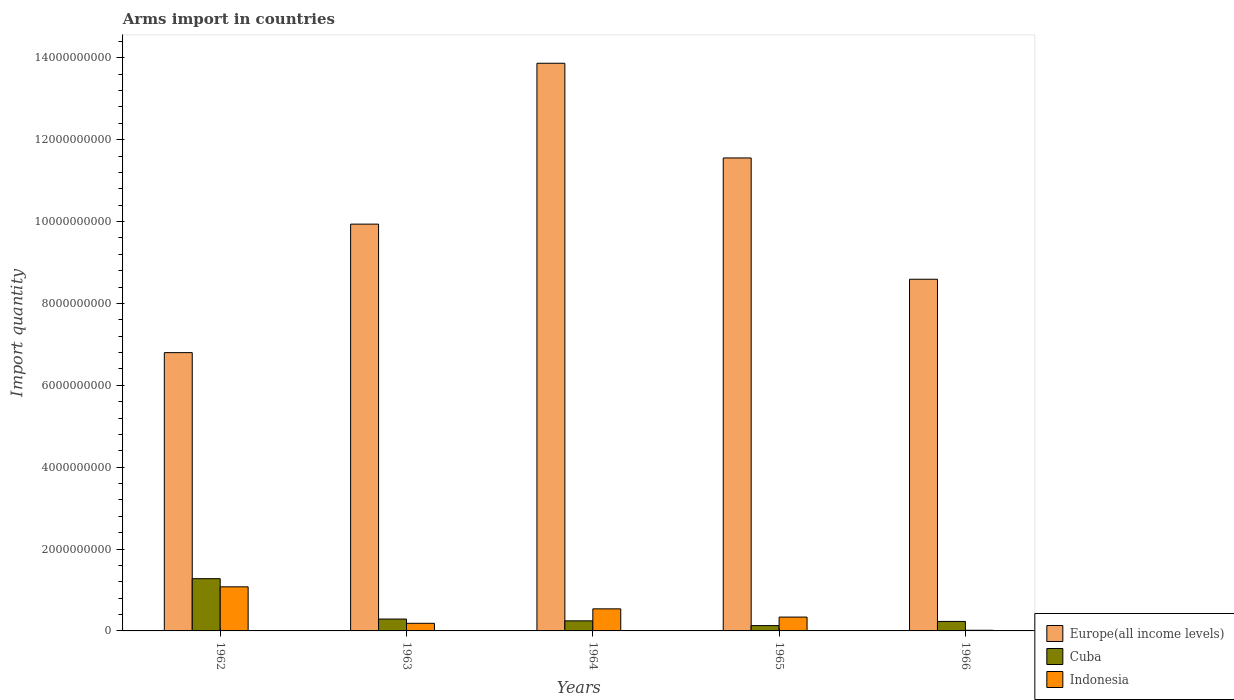Are the number of bars per tick equal to the number of legend labels?
Offer a very short reply. Yes. Are the number of bars on each tick of the X-axis equal?
Your response must be concise. Yes. How many bars are there on the 2nd tick from the right?
Your answer should be very brief. 3. What is the label of the 5th group of bars from the left?
Provide a succinct answer. 1966. What is the total arms import in Cuba in 1963?
Your response must be concise. 2.90e+08. Across all years, what is the maximum total arms import in Indonesia?
Offer a very short reply. 1.08e+09. Across all years, what is the minimum total arms import in Europe(all income levels)?
Offer a terse response. 6.80e+09. In which year was the total arms import in Europe(all income levels) minimum?
Offer a very short reply. 1962. What is the total total arms import in Indonesia in the graph?
Your answer should be compact. 2.16e+09. What is the difference between the total arms import in Cuba in 1964 and that in 1966?
Make the answer very short. 1.40e+07. What is the difference between the total arms import in Indonesia in 1962 and the total arms import in Cuba in 1964?
Provide a succinct answer. 8.31e+08. What is the average total arms import in Indonesia per year?
Provide a short and direct response. 4.31e+08. In the year 1962, what is the difference between the total arms import in Cuba and total arms import in Europe(all income levels)?
Provide a succinct answer. -5.52e+09. What is the ratio of the total arms import in Europe(all income levels) in 1963 to that in 1964?
Your answer should be compact. 0.72. Is the total arms import in Indonesia in 1965 less than that in 1966?
Offer a terse response. No. Is the difference between the total arms import in Cuba in 1964 and 1966 greater than the difference between the total arms import in Europe(all income levels) in 1964 and 1966?
Your response must be concise. No. What is the difference between the highest and the second highest total arms import in Indonesia?
Your response must be concise. 5.38e+08. What is the difference between the highest and the lowest total arms import in Cuba?
Offer a terse response. 1.15e+09. What does the 2nd bar from the right in 1964 represents?
Offer a terse response. Cuba. Are all the bars in the graph horizontal?
Offer a terse response. No. What is the difference between two consecutive major ticks on the Y-axis?
Offer a terse response. 2.00e+09. How are the legend labels stacked?
Provide a short and direct response. Vertical. What is the title of the graph?
Ensure brevity in your answer.  Arms import in countries. Does "New Caledonia" appear as one of the legend labels in the graph?
Offer a terse response. No. What is the label or title of the Y-axis?
Provide a short and direct response. Import quantity. What is the Import quantity in Europe(all income levels) in 1962?
Offer a very short reply. 6.80e+09. What is the Import quantity of Cuba in 1962?
Make the answer very short. 1.28e+09. What is the Import quantity in Indonesia in 1962?
Provide a short and direct response. 1.08e+09. What is the Import quantity in Europe(all income levels) in 1963?
Keep it short and to the point. 9.94e+09. What is the Import quantity of Cuba in 1963?
Provide a short and direct response. 2.90e+08. What is the Import quantity in Indonesia in 1963?
Your answer should be compact. 1.86e+08. What is the Import quantity in Europe(all income levels) in 1964?
Provide a succinct answer. 1.39e+1. What is the Import quantity of Cuba in 1964?
Make the answer very short. 2.46e+08. What is the Import quantity of Indonesia in 1964?
Keep it short and to the point. 5.39e+08. What is the Import quantity of Europe(all income levels) in 1965?
Give a very brief answer. 1.16e+1. What is the Import quantity in Cuba in 1965?
Offer a very short reply. 1.30e+08. What is the Import quantity of Indonesia in 1965?
Your answer should be very brief. 3.38e+08. What is the Import quantity of Europe(all income levels) in 1966?
Your response must be concise. 8.59e+09. What is the Import quantity in Cuba in 1966?
Provide a succinct answer. 2.32e+08. What is the Import quantity of Indonesia in 1966?
Offer a very short reply. 1.60e+07. Across all years, what is the maximum Import quantity in Europe(all income levels)?
Provide a short and direct response. 1.39e+1. Across all years, what is the maximum Import quantity in Cuba?
Provide a short and direct response. 1.28e+09. Across all years, what is the maximum Import quantity in Indonesia?
Offer a very short reply. 1.08e+09. Across all years, what is the minimum Import quantity of Europe(all income levels)?
Ensure brevity in your answer.  6.80e+09. Across all years, what is the minimum Import quantity of Cuba?
Keep it short and to the point. 1.30e+08. Across all years, what is the minimum Import quantity in Indonesia?
Your answer should be compact. 1.60e+07. What is the total Import quantity of Europe(all income levels) in the graph?
Offer a terse response. 5.07e+1. What is the total Import quantity in Cuba in the graph?
Offer a very short reply. 2.17e+09. What is the total Import quantity of Indonesia in the graph?
Offer a very short reply. 2.16e+09. What is the difference between the Import quantity of Europe(all income levels) in 1962 and that in 1963?
Your answer should be compact. -3.14e+09. What is the difference between the Import quantity of Cuba in 1962 and that in 1963?
Ensure brevity in your answer.  9.86e+08. What is the difference between the Import quantity in Indonesia in 1962 and that in 1963?
Ensure brevity in your answer.  8.91e+08. What is the difference between the Import quantity in Europe(all income levels) in 1962 and that in 1964?
Keep it short and to the point. -7.07e+09. What is the difference between the Import quantity of Cuba in 1962 and that in 1964?
Keep it short and to the point. 1.03e+09. What is the difference between the Import quantity of Indonesia in 1962 and that in 1964?
Your answer should be compact. 5.38e+08. What is the difference between the Import quantity of Europe(all income levels) in 1962 and that in 1965?
Make the answer very short. -4.76e+09. What is the difference between the Import quantity of Cuba in 1962 and that in 1965?
Ensure brevity in your answer.  1.15e+09. What is the difference between the Import quantity in Indonesia in 1962 and that in 1965?
Provide a short and direct response. 7.39e+08. What is the difference between the Import quantity of Europe(all income levels) in 1962 and that in 1966?
Provide a succinct answer. -1.79e+09. What is the difference between the Import quantity of Cuba in 1962 and that in 1966?
Offer a terse response. 1.04e+09. What is the difference between the Import quantity in Indonesia in 1962 and that in 1966?
Your answer should be compact. 1.06e+09. What is the difference between the Import quantity of Europe(all income levels) in 1963 and that in 1964?
Provide a short and direct response. -3.93e+09. What is the difference between the Import quantity of Cuba in 1963 and that in 1964?
Offer a terse response. 4.40e+07. What is the difference between the Import quantity of Indonesia in 1963 and that in 1964?
Your answer should be very brief. -3.53e+08. What is the difference between the Import quantity in Europe(all income levels) in 1963 and that in 1965?
Your response must be concise. -1.62e+09. What is the difference between the Import quantity of Cuba in 1963 and that in 1965?
Ensure brevity in your answer.  1.60e+08. What is the difference between the Import quantity in Indonesia in 1963 and that in 1965?
Your answer should be very brief. -1.52e+08. What is the difference between the Import quantity of Europe(all income levels) in 1963 and that in 1966?
Give a very brief answer. 1.35e+09. What is the difference between the Import quantity in Cuba in 1963 and that in 1966?
Your answer should be compact. 5.80e+07. What is the difference between the Import quantity of Indonesia in 1963 and that in 1966?
Your answer should be very brief. 1.70e+08. What is the difference between the Import quantity in Europe(all income levels) in 1964 and that in 1965?
Provide a short and direct response. 2.31e+09. What is the difference between the Import quantity of Cuba in 1964 and that in 1965?
Your answer should be very brief. 1.16e+08. What is the difference between the Import quantity of Indonesia in 1964 and that in 1965?
Provide a succinct answer. 2.01e+08. What is the difference between the Import quantity of Europe(all income levels) in 1964 and that in 1966?
Provide a succinct answer. 5.28e+09. What is the difference between the Import quantity in Cuba in 1964 and that in 1966?
Your answer should be compact. 1.40e+07. What is the difference between the Import quantity of Indonesia in 1964 and that in 1966?
Offer a terse response. 5.23e+08. What is the difference between the Import quantity in Europe(all income levels) in 1965 and that in 1966?
Give a very brief answer. 2.96e+09. What is the difference between the Import quantity in Cuba in 1965 and that in 1966?
Your answer should be compact. -1.02e+08. What is the difference between the Import quantity of Indonesia in 1965 and that in 1966?
Provide a short and direct response. 3.22e+08. What is the difference between the Import quantity of Europe(all income levels) in 1962 and the Import quantity of Cuba in 1963?
Offer a very short reply. 6.51e+09. What is the difference between the Import quantity of Europe(all income levels) in 1962 and the Import quantity of Indonesia in 1963?
Keep it short and to the point. 6.61e+09. What is the difference between the Import quantity of Cuba in 1962 and the Import quantity of Indonesia in 1963?
Keep it short and to the point. 1.09e+09. What is the difference between the Import quantity of Europe(all income levels) in 1962 and the Import quantity of Cuba in 1964?
Provide a succinct answer. 6.55e+09. What is the difference between the Import quantity of Europe(all income levels) in 1962 and the Import quantity of Indonesia in 1964?
Offer a terse response. 6.26e+09. What is the difference between the Import quantity in Cuba in 1962 and the Import quantity in Indonesia in 1964?
Provide a succinct answer. 7.37e+08. What is the difference between the Import quantity in Europe(all income levels) in 1962 and the Import quantity in Cuba in 1965?
Offer a terse response. 6.67e+09. What is the difference between the Import quantity of Europe(all income levels) in 1962 and the Import quantity of Indonesia in 1965?
Provide a short and direct response. 6.46e+09. What is the difference between the Import quantity in Cuba in 1962 and the Import quantity in Indonesia in 1965?
Your answer should be compact. 9.38e+08. What is the difference between the Import quantity of Europe(all income levels) in 1962 and the Import quantity of Cuba in 1966?
Offer a very short reply. 6.57e+09. What is the difference between the Import quantity in Europe(all income levels) in 1962 and the Import quantity in Indonesia in 1966?
Provide a short and direct response. 6.78e+09. What is the difference between the Import quantity of Cuba in 1962 and the Import quantity of Indonesia in 1966?
Offer a terse response. 1.26e+09. What is the difference between the Import quantity in Europe(all income levels) in 1963 and the Import quantity in Cuba in 1964?
Your answer should be compact. 9.69e+09. What is the difference between the Import quantity of Europe(all income levels) in 1963 and the Import quantity of Indonesia in 1964?
Ensure brevity in your answer.  9.40e+09. What is the difference between the Import quantity in Cuba in 1963 and the Import quantity in Indonesia in 1964?
Give a very brief answer. -2.49e+08. What is the difference between the Import quantity of Europe(all income levels) in 1963 and the Import quantity of Cuba in 1965?
Give a very brief answer. 9.81e+09. What is the difference between the Import quantity in Europe(all income levels) in 1963 and the Import quantity in Indonesia in 1965?
Provide a succinct answer. 9.60e+09. What is the difference between the Import quantity in Cuba in 1963 and the Import quantity in Indonesia in 1965?
Your answer should be very brief. -4.80e+07. What is the difference between the Import quantity of Europe(all income levels) in 1963 and the Import quantity of Cuba in 1966?
Provide a succinct answer. 9.70e+09. What is the difference between the Import quantity of Europe(all income levels) in 1963 and the Import quantity of Indonesia in 1966?
Offer a terse response. 9.92e+09. What is the difference between the Import quantity in Cuba in 1963 and the Import quantity in Indonesia in 1966?
Keep it short and to the point. 2.74e+08. What is the difference between the Import quantity of Europe(all income levels) in 1964 and the Import quantity of Cuba in 1965?
Your answer should be compact. 1.37e+1. What is the difference between the Import quantity of Europe(all income levels) in 1964 and the Import quantity of Indonesia in 1965?
Provide a short and direct response. 1.35e+1. What is the difference between the Import quantity in Cuba in 1964 and the Import quantity in Indonesia in 1965?
Offer a very short reply. -9.20e+07. What is the difference between the Import quantity of Europe(all income levels) in 1964 and the Import quantity of Cuba in 1966?
Your response must be concise. 1.36e+1. What is the difference between the Import quantity in Europe(all income levels) in 1964 and the Import quantity in Indonesia in 1966?
Your answer should be very brief. 1.39e+1. What is the difference between the Import quantity of Cuba in 1964 and the Import quantity of Indonesia in 1966?
Your answer should be compact. 2.30e+08. What is the difference between the Import quantity of Europe(all income levels) in 1965 and the Import quantity of Cuba in 1966?
Keep it short and to the point. 1.13e+1. What is the difference between the Import quantity of Europe(all income levels) in 1965 and the Import quantity of Indonesia in 1966?
Ensure brevity in your answer.  1.15e+1. What is the difference between the Import quantity in Cuba in 1965 and the Import quantity in Indonesia in 1966?
Make the answer very short. 1.14e+08. What is the average Import quantity in Europe(all income levels) per year?
Provide a succinct answer. 1.01e+1. What is the average Import quantity of Cuba per year?
Your answer should be very brief. 4.35e+08. What is the average Import quantity in Indonesia per year?
Provide a succinct answer. 4.31e+08. In the year 1962, what is the difference between the Import quantity in Europe(all income levels) and Import quantity in Cuba?
Ensure brevity in your answer.  5.52e+09. In the year 1962, what is the difference between the Import quantity in Europe(all income levels) and Import quantity in Indonesia?
Give a very brief answer. 5.72e+09. In the year 1962, what is the difference between the Import quantity of Cuba and Import quantity of Indonesia?
Your response must be concise. 1.99e+08. In the year 1963, what is the difference between the Import quantity of Europe(all income levels) and Import quantity of Cuba?
Make the answer very short. 9.65e+09. In the year 1963, what is the difference between the Import quantity in Europe(all income levels) and Import quantity in Indonesia?
Ensure brevity in your answer.  9.75e+09. In the year 1963, what is the difference between the Import quantity in Cuba and Import quantity in Indonesia?
Offer a very short reply. 1.04e+08. In the year 1964, what is the difference between the Import quantity of Europe(all income levels) and Import quantity of Cuba?
Make the answer very short. 1.36e+1. In the year 1964, what is the difference between the Import quantity of Europe(all income levels) and Import quantity of Indonesia?
Provide a short and direct response. 1.33e+1. In the year 1964, what is the difference between the Import quantity in Cuba and Import quantity in Indonesia?
Your answer should be compact. -2.93e+08. In the year 1965, what is the difference between the Import quantity of Europe(all income levels) and Import quantity of Cuba?
Provide a succinct answer. 1.14e+1. In the year 1965, what is the difference between the Import quantity in Europe(all income levels) and Import quantity in Indonesia?
Ensure brevity in your answer.  1.12e+1. In the year 1965, what is the difference between the Import quantity of Cuba and Import quantity of Indonesia?
Provide a succinct answer. -2.08e+08. In the year 1966, what is the difference between the Import quantity of Europe(all income levels) and Import quantity of Cuba?
Your answer should be compact. 8.36e+09. In the year 1966, what is the difference between the Import quantity in Europe(all income levels) and Import quantity in Indonesia?
Ensure brevity in your answer.  8.58e+09. In the year 1966, what is the difference between the Import quantity of Cuba and Import quantity of Indonesia?
Ensure brevity in your answer.  2.16e+08. What is the ratio of the Import quantity in Europe(all income levels) in 1962 to that in 1963?
Your answer should be compact. 0.68. What is the ratio of the Import quantity of Cuba in 1962 to that in 1963?
Provide a succinct answer. 4.4. What is the ratio of the Import quantity of Indonesia in 1962 to that in 1963?
Give a very brief answer. 5.79. What is the ratio of the Import quantity of Europe(all income levels) in 1962 to that in 1964?
Your response must be concise. 0.49. What is the ratio of the Import quantity in Cuba in 1962 to that in 1964?
Your answer should be very brief. 5.19. What is the ratio of the Import quantity in Indonesia in 1962 to that in 1964?
Offer a very short reply. 2. What is the ratio of the Import quantity of Europe(all income levels) in 1962 to that in 1965?
Make the answer very short. 0.59. What is the ratio of the Import quantity of Cuba in 1962 to that in 1965?
Provide a short and direct response. 9.82. What is the ratio of the Import quantity of Indonesia in 1962 to that in 1965?
Offer a terse response. 3.19. What is the ratio of the Import quantity in Europe(all income levels) in 1962 to that in 1966?
Offer a very short reply. 0.79. What is the ratio of the Import quantity of Indonesia in 1962 to that in 1966?
Ensure brevity in your answer.  67.31. What is the ratio of the Import quantity of Europe(all income levels) in 1963 to that in 1964?
Your answer should be compact. 0.72. What is the ratio of the Import quantity of Cuba in 1963 to that in 1964?
Offer a terse response. 1.18. What is the ratio of the Import quantity in Indonesia in 1963 to that in 1964?
Your answer should be compact. 0.35. What is the ratio of the Import quantity of Europe(all income levels) in 1963 to that in 1965?
Your response must be concise. 0.86. What is the ratio of the Import quantity in Cuba in 1963 to that in 1965?
Your answer should be very brief. 2.23. What is the ratio of the Import quantity of Indonesia in 1963 to that in 1965?
Keep it short and to the point. 0.55. What is the ratio of the Import quantity in Europe(all income levels) in 1963 to that in 1966?
Provide a succinct answer. 1.16. What is the ratio of the Import quantity in Indonesia in 1963 to that in 1966?
Your response must be concise. 11.62. What is the ratio of the Import quantity of Europe(all income levels) in 1964 to that in 1965?
Your answer should be very brief. 1.2. What is the ratio of the Import quantity of Cuba in 1964 to that in 1965?
Make the answer very short. 1.89. What is the ratio of the Import quantity of Indonesia in 1964 to that in 1965?
Your answer should be compact. 1.59. What is the ratio of the Import quantity of Europe(all income levels) in 1964 to that in 1966?
Provide a succinct answer. 1.61. What is the ratio of the Import quantity in Cuba in 1964 to that in 1966?
Provide a short and direct response. 1.06. What is the ratio of the Import quantity in Indonesia in 1964 to that in 1966?
Keep it short and to the point. 33.69. What is the ratio of the Import quantity in Europe(all income levels) in 1965 to that in 1966?
Offer a terse response. 1.34. What is the ratio of the Import quantity in Cuba in 1965 to that in 1966?
Your answer should be very brief. 0.56. What is the ratio of the Import quantity in Indonesia in 1965 to that in 1966?
Your answer should be very brief. 21.12. What is the difference between the highest and the second highest Import quantity in Europe(all income levels)?
Provide a short and direct response. 2.31e+09. What is the difference between the highest and the second highest Import quantity in Cuba?
Your answer should be compact. 9.86e+08. What is the difference between the highest and the second highest Import quantity in Indonesia?
Make the answer very short. 5.38e+08. What is the difference between the highest and the lowest Import quantity of Europe(all income levels)?
Give a very brief answer. 7.07e+09. What is the difference between the highest and the lowest Import quantity of Cuba?
Offer a very short reply. 1.15e+09. What is the difference between the highest and the lowest Import quantity of Indonesia?
Ensure brevity in your answer.  1.06e+09. 